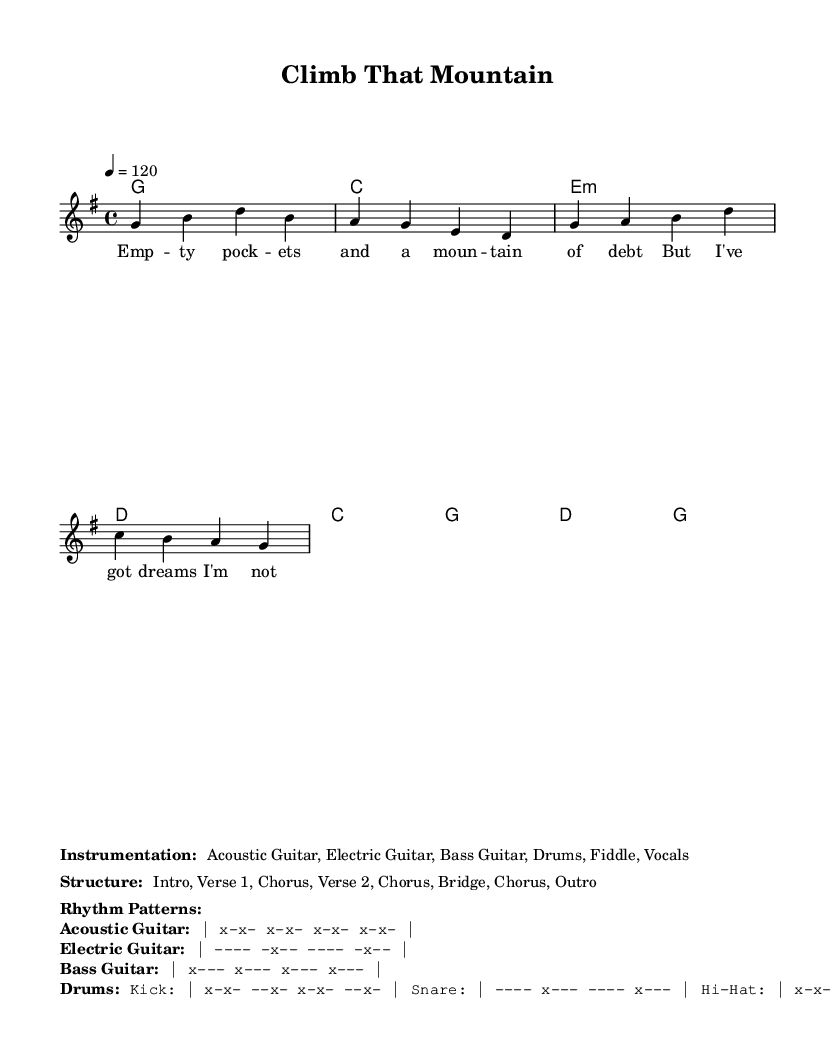What is the key signature of this music? The key signature is G major, which has one sharp (F#). This can be identified in the global settings of the music sheet.
Answer: G major What is the time signature of this piece? The time signature is 4/4, indicating that there are four beats per measure. This is also stated in the global settings of the sheet music.
Answer: 4/4 What is the tempo marking for this song? The tempo marking indicates a speed of 120 beats per minute. This is explicitly written as "4 = 120" in the global section of the sheet music.
Answer: 120 How many verses are in the song structure? The song structure includes two verses as described in the breakdown: Intro, Verse 1, Chorus, Verse 2, Chorus, Bridge, Chorus, Outro. Thus, there are two distinct verses.
Answer: 2 What is the main theme of the song? The main theme of the song revolves around perseverance and overcoming economic challenges, as reflected in the lyrics discussing empty pockets and climbing a mountain.
Answer: Perseverance What is the instrumentation used in this piece? The instrumentation comprises Acoustic Guitar, Electric Guitar, Bass Guitar, Drums, Fiddle, and Vocals as stated in the markups provided in the sheet music.
Answer: Acoustic Guitar, Electric Guitar, Bass Guitar, Drums, Fiddle, Vocals What rhythm pattern is used for the Electric Guitar? The rhythm pattern for the Electric Guitar is described as "---- -x-- ---- -x--", indicating a strumming pattern with specific beats emphasized. This is detailed in the rhythm patterns section of the markup.
Answer: ---- -x-- ---- -x-- 